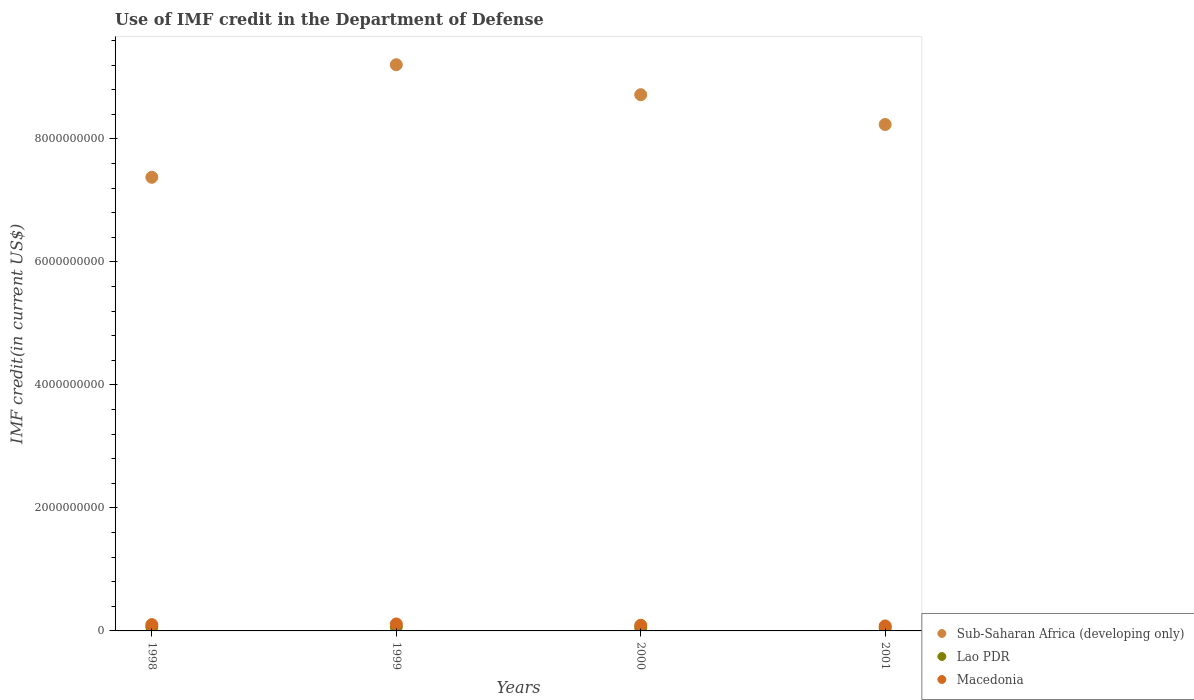Is the number of dotlines equal to the number of legend labels?
Offer a very short reply. Yes. What is the IMF credit in the Department of Defense in Macedonia in 2001?
Keep it short and to the point. 8.13e+07. Across all years, what is the maximum IMF credit in the Department of Defense in Sub-Saharan Africa (developing only)?
Your answer should be compact. 9.21e+09. Across all years, what is the minimum IMF credit in the Department of Defense in Sub-Saharan Africa (developing only)?
Provide a short and direct response. 7.38e+09. In which year was the IMF credit in the Department of Defense in Lao PDR maximum?
Keep it short and to the point. 1999. In which year was the IMF credit in the Department of Defense in Lao PDR minimum?
Offer a very short reply. 2001. What is the total IMF credit in the Department of Defense in Sub-Saharan Africa (developing only) in the graph?
Make the answer very short. 3.35e+1. What is the difference between the IMF credit in the Department of Defense in Lao PDR in 1998 and that in 1999?
Make the answer very short. -3.30e+06. What is the difference between the IMF credit in the Department of Defense in Macedonia in 1998 and the IMF credit in the Department of Defense in Lao PDR in 2001?
Offer a very short reply. 5.32e+07. What is the average IMF credit in the Department of Defense in Sub-Saharan Africa (developing only) per year?
Your answer should be very brief. 8.38e+09. In the year 2001, what is the difference between the IMF credit in the Department of Defense in Macedonia and IMF credit in the Department of Defense in Sub-Saharan Africa (developing only)?
Your answer should be very brief. -8.15e+09. In how many years, is the IMF credit in the Department of Defense in Sub-Saharan Africa (developing only) greater than 7600000000 US$?
Make the answer very short. 3. What is the ratio of the IMF credit in the Department of Defense in Sub-Saharan Africa (developing only) in 2000 to that in 2001?
Your response must be concise. 1.06. Is the IMF credit in the Department of Defense in Sub-Saharan Africa (developing only) in 1999 less than that in 2000?
Your response must be concise. No. What is the difference between the highest and the second highest IMF credit in the Department of Defense in Sub-Saharan Africa (developing only)?
Your answer should be very brief. 4.88e+08. What is the difference between the highest and the lowest IMF credit in the Department of Defense in Macedonia?
Keep it short and to the point. 3.19e+07. In how many years, is the IMF credit in the Department of Defense in Lao PDR greater than the average IMF credit in the Department of Defense in Lao PDR taken over all years?
Your response must be concise. 2. How many dotlines are there?
Keep it short and to the point. 3. Does the graph contain any zero values?
Your response must be concise. No. How many legend labels are there?
Keep it short and to the point. 3. What is the title of the graph?
Provide a succinct answer. Use of IMF credit in the Department of Defense. What is the label or title of the X-axis?
Provide a short and direct response. Years. What is the label or title of the Y-axis?
Offer a terse response. IMF credit(in current US$). What is the IMF credit(in current US$) of Sub-Saharan Africa (developing only) in 1998?
Offer a very short reply. 7.38e+09. What is the IMF credit(in current US$) in Lao PDR in 1998?
Offer a terse response. 6.23e+07. What is the IMF credit(in current US$) of Macedonia in 1998?
Ensure brevity in your answer.  1.02e+08. What is the IMF credit(in current US$) in Sub-Saharan Africa (developing only) in 1999?
Give a very brief answer. 9.21e+09. What is the IMF credit(in current US$) in Lao PDR in 1999?
Ensure brevity in your answer.  6.56e+07. What is the IMF credit(in current US$) of Macedonia in 1999?
Ensure brevity in your answer.  1.13e+08. What is the IMF credit(in current US$) of Sub-Saharan Africa (developing only) in 2000?
Offer a terse response. 8.72e+09. What is the IMF credit(in current US$) of Lao PDR in 2000?
Offer a very short reply. 5.47e+07. What is the IMF credit(in current US$) of Macedonia in 2000?
Your answer should be very brief. 9.21e+07. What is the IMF credit(in current US$) of Sub-Saharan Africa (developing only) in 2001?
Your answer should be very brief. 8.24e+09. What is the IMF credit(in current US$) in Lao PDR in 2001?
Ensure brevity in your answer.  4.92e+07. What is the IMF credit(in current US$) of Macedonia in 2001?
Your response must be concise. 8.13e+07. Across all years, what is the maximum IMF credit(in current US$) of Sub-Saharan Africa (developing only)?
Provide a short and direct response. 9.21e+09. Across all years, what is the maximum IMF credit(in current US$) of Lao PDR?
Your answer should be compact. 6.56e+07. Across all years, what is the maximum IMF credit(in current US$) of Macedonia?
Your answer should be compact. 1.13e+08. Across all years, what is the minimum IMF credit(in current US$) in Sub-Saharan Africa (developing only)?
Keep it short and to the point. 7.38e+09. Across all years, what is the minimum IMF credit(in current US$) of Lao PDR?
Ensure brevity in your answer.  4.92e+07. Across all years, what is the minimum IMF credit(in current US$) in Macedonia?
Keep it short and to the point. 8.13e+07. What is the total IMF credit(in current US$) in Sub-Saharan Africa (developing only) in the graph?
Offer a very short reply. 3.35e+1. What is the total IMF credit(in current US$) of Lao PDR in the graph?
Give a very brief answer. 2.32e+08. What is the total IMF credit(in current US$) of Macedonia in the graph?
Your response must be concise. 3.89e+08. What is the difference between the IMF credit(in current US$) in Sub-Saharan Africa (developing only) in 1998 and that in 1999?
Make the answer very short. -1.83e+09. What is the difference between the IMF credit(in current US$) in Lao PDR in 1998 and that in 1999?
Your answer should be very brief. -3.30e+06. What is the difference between the IMF credit(in current US$) in Macedonia in 1998 and that in 1999?
Ensure brevity in your answer.  -1.08e+07. What is the difference between the IMF credit(in current US$) of Sub-Saharan Africa (developing only) in 1998 and that in 2000?
Ensure brevity in your answer.  -1.34e+09. What is the difference between the IMF credit(in current US$) of Lao PDR in 1998 and that in 2000?
Keep it short and to the point. 7.67e+06. What is the difference between the IMF credit(in current US$) of Macedonia in 1998 and that in 2000?
Offer a very short reply. 1.03e+07. What is the difference between the IMF credit(in current US$) in Sub-Saharan Africa (developing only) in 1998 and that in 2001?
Your answer should be very brief. -8.58e+08. What is the difference between the IMF credit(in current US$) in Lao PDR in 1998 and that in 2001?
Ensure brevity in your answer.  1.31e+07. What is the difference between the IMF credit(in current US$) of Macedonia in 1998 and that in 2001?
Your answer should be compact. 2.11e+07. What is the difference between the IMF credit(in current US$) of Sub-Saharan Africa (developing only) in 1999 and that in 2000?
Give a very brief answer. 4.88e+08. What is the difference between the IMF credit(in current US$) of Lao PDR in 1999 and that in 2000?
Provide a short and direct response. 1.10e+07. What is the difference between the IMF credit(in current US$) in Macedonia in 1999 and that in 2000?
Offer a terse response. 2.11e+07. What is the difference between the IMF credit(in current US$) in Sub-Saharan Africa (developing only) in 1999 and that in 2001?
Give a very brief answer. 9.72e+08. What is the difference between the IMF credit(in current US$) in Lao PDR in 1999 and that in 2001?
Keep it short and to the point. 1.64e+07. What is the difference between the IMF credit(in current US$) of Macedonia in 1999 and that in 2001?
Ensure brevity in your answer.  3.19e+07. What is the difference between the IMF credit(in current US$) of Sub-Saharan Africa (developing only) in 2000 and that in 2001?
Make the answer very short. 4.84e+08. What is the difference between the IMF credit(in current US$) of Lao PDR in 2000 and that in 2001?
Offer a very short reply. 5.46e+06. What is the difference between the IMF credit(in current US$) in Macedonia in 2000 and that in 2001?
Offer a terse response. 1.08e+07. What is the difference between the IMF credit(in current US$) of Sub-Saharan Africa (developing only) in 1998 and the IMF credit(in current US$) of Lao PDR in 1999?
Your response must be concise. 7.31e+09. What is the difference between the IMF credit(in current US$) in Sub-Saharan Africa (developing only) in 1998 and the IMF credit(in current US$) in Macedonia in 1999?
Give a very brief answer. 7.26e+09. What is the difference between the IMF credit(in current US$) in Lao PDR in 1998 and the IMF credit(in current US$) in Macedonia in 1999?
Provide a short and direct response. -5.09e+07. What is the difference between the IMF credit(in current US$) in Sub-Saharan Africa (developing only) in 1998 and the IMF credit(in current US$) in Lao PDR in 2000?
Offer a terse response. 7.32e+09. What is the difference between the IMF credit(in current US$) in Sub-Saharan Africa (developing only) in 1998 and the IMF credit(in current US$) in Macedonia in 2000?
Offer a terse response. 7.28e+09. What is the difference between the IMF credit(in current US$) in Lao PDR in 1998 and the IMF credit(in current US$) in Macedonia in 2000?
Offer a very short reply. -2.98e+07. What is the difference between the IMF credit(in current US$) in Sub-Saharan Africa (developing only) in 1998 and the IMF credit(in current US$) in Lao PDR in 2001?
Give a very brief answer. 7.33e+09. What is the difference between the IMF credit(in current US$) in Sub-Saharan Africa (developing only) in 1998 and the IMF credit(in current US$) in Macedonia in 2001?
Keep it short and to the point. 7.30e+09. What is the difference between the IMF credit(in current US$) in Lao PDR in 1998 and the IMF credit(in current US$) in Macedonia in 2001?
Ensure brevity in your answer.  -1.90e+07. What is the difference between the IMF credit(in current US$) of Sub-Saharan Africa (developing only) in 1999 and the IMF credit(in current US$) of Lao PDR in 2000?
Give a very brief answer. 9.15e+09. What is the difference between the IMF credit(in current US$) in Sub-Saharan Africa (developing only) in 1999 and the IMF credit(in current US$) in Macedonia in 2000?
Ensure brevity in your answer.  9.11e+09. What is the difference between the IMF credit(in current US$) in Lao PDR in 1999 and the IMF credit(in current US$) in Macedonia in 2000?
Your answer should be very brief. -2.65e+07. What is the difference between the IMF credit(in current US$) of Sub-Saharan Africa (developing only) in 1999 and the IMF credit(in current US$) of Lao PDR in 2001?
Ensure brevity in your answer.  9.16e+09. What is the difference between the IMF credit(in current US$) of Sub-Saharan Africa (developing only) in 1999 and the IMF credit(in current US$) of Macedonia in 2001?
Give a very brief answer. 9.13e+09. What is the difference between the IMF credit(in current US$) in Lao PDR in 1999 and the IMF credit(in current US$) in Macedonia in 2001?
Make the answer very short. -1.57e+07. What is the difference between the IMF credit(in current US$) in Sub-Saharan Africa (developing only) in 2000 and the IMF credit(in current US$) in Lao PDR in 2001?
Offer a terse response. 8.67e+09. What is the difference between the IMF credit(in current US$) in Sub-Saharan Africa (developing only) in 2000 and the IMF credit(in current US$) in Macedonia in 2001?
Offer a very short reply. 8.64e+09. What is the difference between the IMF credit(in current US$) in Lao PDR in 2000 and the IMF credit(in current US$) in Macedonia in 2001?
Provide a succinct answer. -2.67e+07. What is the average IMF credit(in current US$) in Sub-Saharan Africa (developing only) per year?
Offer a terse response. 8.38e+09. What is the average IMF credit(in current US$) of Lao PDR per year?
Your answer should be compact. 5.80e+07. What is the average IMF credit(in current US$) in Macedonia per year?
Your answer should be very brief. 9.73e+07. In the year 1998, what is the difference between the IMF credit(in current US$) of Sub-Saharan Africa (developing only) and IMF credit(in current US$) of Lao PDR?
Offer a very short reply. 7.31e+09. In the year 1998, what is the difference between the IMF credit(in current US$) in Sub-Saharan Africa (developing only) and IMF credit(in current US$) in Macedonia?
Your answer should be very brief. 7.27e+09. In the year 1998, what is the difference between the IMF credit(in current US$) in Lao PDR and IMF credit(in current US$) in Macedonia?
Your answer should be compact. -4.01e+07. In the year 1999, what is the difference between the IMF credit(in current US$) of Sub-Saharan Africa (developing only) and IMF credit(in current US$) of Lao PDR?
Make the answer very short. 9.14e+09. In the year 1999, what is the difference between the IMF credit(in current US$) in Sub-Saharan Africa (developing only) and IMF credit(in current US$) in Macedonia?
Ensure brevity in your answer.  9.09e+09. In the year 1999, what is the difference between the IMF credit(in current US$) in Lao PDR and IMF credit(in current US$) in Macedonia?
Offer a very short reply. -4.76e+07. In the year 2000, what is the difference between the IMF credit(in current US$) of Sub-Saharan Africa (developing only) and IMF credit(in current US$) of Lao PDR?
Give a very brief answer. 8.66e+09. In the year 2000, what is the difference between the IMF credit(in current US$) in Sub-Saharan Africa (developing only) and IMF credit(in current US$) in Macedonia?
Your answer should be compact. 8.63e+09. In the year 2000, what is the difference between the IMF credit(in current US$) in Lao PDR and IMF credit(in current US$) in Macedonia?
Your answer should be very brief. -3.74e+07. In the year 2001, what is the difference between the IMF credit(in current US$) in Sub-Saharan Africa (developing only) and IMF credit(in current US$) in Lao PDR?
Ensure brevity in your answer.  8.19e+09. In the year 2001, what is the difference between the IMF credit(in current US$) in Sub-Saharan Africa (developing only) and IMF credit(in current US$) in Macedonia?
Give a very brief answer. 8.15e+09. In the year 2001, what is the difference between the IMF credit(in current US$) in Lao PDR and IMF credit(in current US$) in Macedonia?
Give a very brief answer. -3.21e+07. What is the ratio of the IMF credit(in current US$) of Sub-Saharan Africa (developing only) in 1998 to that in 1999?
Provide a short and direct response. 0.8. What is the ratio of the IMF credit(in current US$) in Lao PDR in 1998 to that in 1999?
Your response must be concise. 0.95. What is the ratio of the IMF credit(in current US$) of Macedonia in 1998 to that in 1999?
Your answer should be compact. 0.9. What is the ratio of the IMF credit(in current US$) of Sub-Saharan Africa (developing only) in 1998 to that in 2000?
Provide a succinct answer. 0.85. What is the ratio of the IMF credit(in current US$) of Lao PDR in 1998 to that in 2000?
Keep it short and to the point. 1.14. What is the ratio of the IMF credit(in current US$) of Macedonia in 1998 to that in 2000?
Your answer should be very brief. 1.11. What is the ratio of the IMF credit(in current US$) of Sub-Saharan Africa (developing only) in 1998 to that in 2001?
Ensure brevity in your answer.  0.9. What is the ratio of the IMF credit(in current US$) in Lao PDR in 1998 to that in 2001?
Ensure brevity in your answer.  1.27. What is the ratio of the IMF credit(in current US$) of Macedonia in 1998 to that in 2001?
Make the answer very short. 1.26. What is the ratio of the IMF credit(in current US$) in Sub-Saharan Africa (developing only) in 1999 to that in 2000?
Provide a short and direct response. 1.06. What is the ratio of the IMF credit(in current US$) in Lao PDR in 1999 to that in 2000?
Your response must be concise. 1.2. What is the ratio of the IMF credit(in current US$) of Macedonia in 1999 to that in 2000?
Your response must be concise. 1.23. What is the ratio of the IMF credit(in current US$) of Sub-Saharan Africa (developing only) in 1999 to that in 2001?
Offer a terse response. 1.12. What is the ratio of the IMF credit(in current US$) of Lao PDR in 1999 to that in 2001?
Your answer should be very brief. 1.33. What is the ratio of the IMF credit(in current US$) of Macedonia in 1999 to that in 2001?
Your answer should be compact. 1.39. What is the ratio of the IMF credit(in current US$) in Sub-Saharan Africa (developing only) in 2000 to that in 2001?
Give a very brief answer. 1.06. What is the ratio of the IMF credit(in current US$) in Lao PDR in 2000 to that in 2001?
Ensure brevity in your answer.  1.11. What is the ratio of the IMF credit(in current US$) of Macedonia in 2000 to that in 2001?
Your answer should be compact. 1.13. What is the difference between the highest and the second highest IMF credit(in current US$) in Sub-Saharan Africa (developing only)?
Make the answer very short. 4.88e+08. What is the difference between the highest and the second highest IMF credit(in current US$) of Lao PDR?
Provide a succinct answer. 3.30e+06. What is the difference between the highest and the second highest IMF credit(in current US$) in Macedonia?
Ensure brevity in your answer.  1.08e+07. What is the difference between the highest and the lowest IMF credit(in current US$) in Sub-Saharan Africa (developing only)?
Your response must be concise. 1.83e+09. What is the difference between the highest and the lowest IMF credit(in current US$) of Lao PDR?
Provide a short and direct response. 1.64e+07. What is the difference between the highest and the lowest IMF credit(in current US$) in Macedonia?
Give a very brief answer. 3.19e+07. 